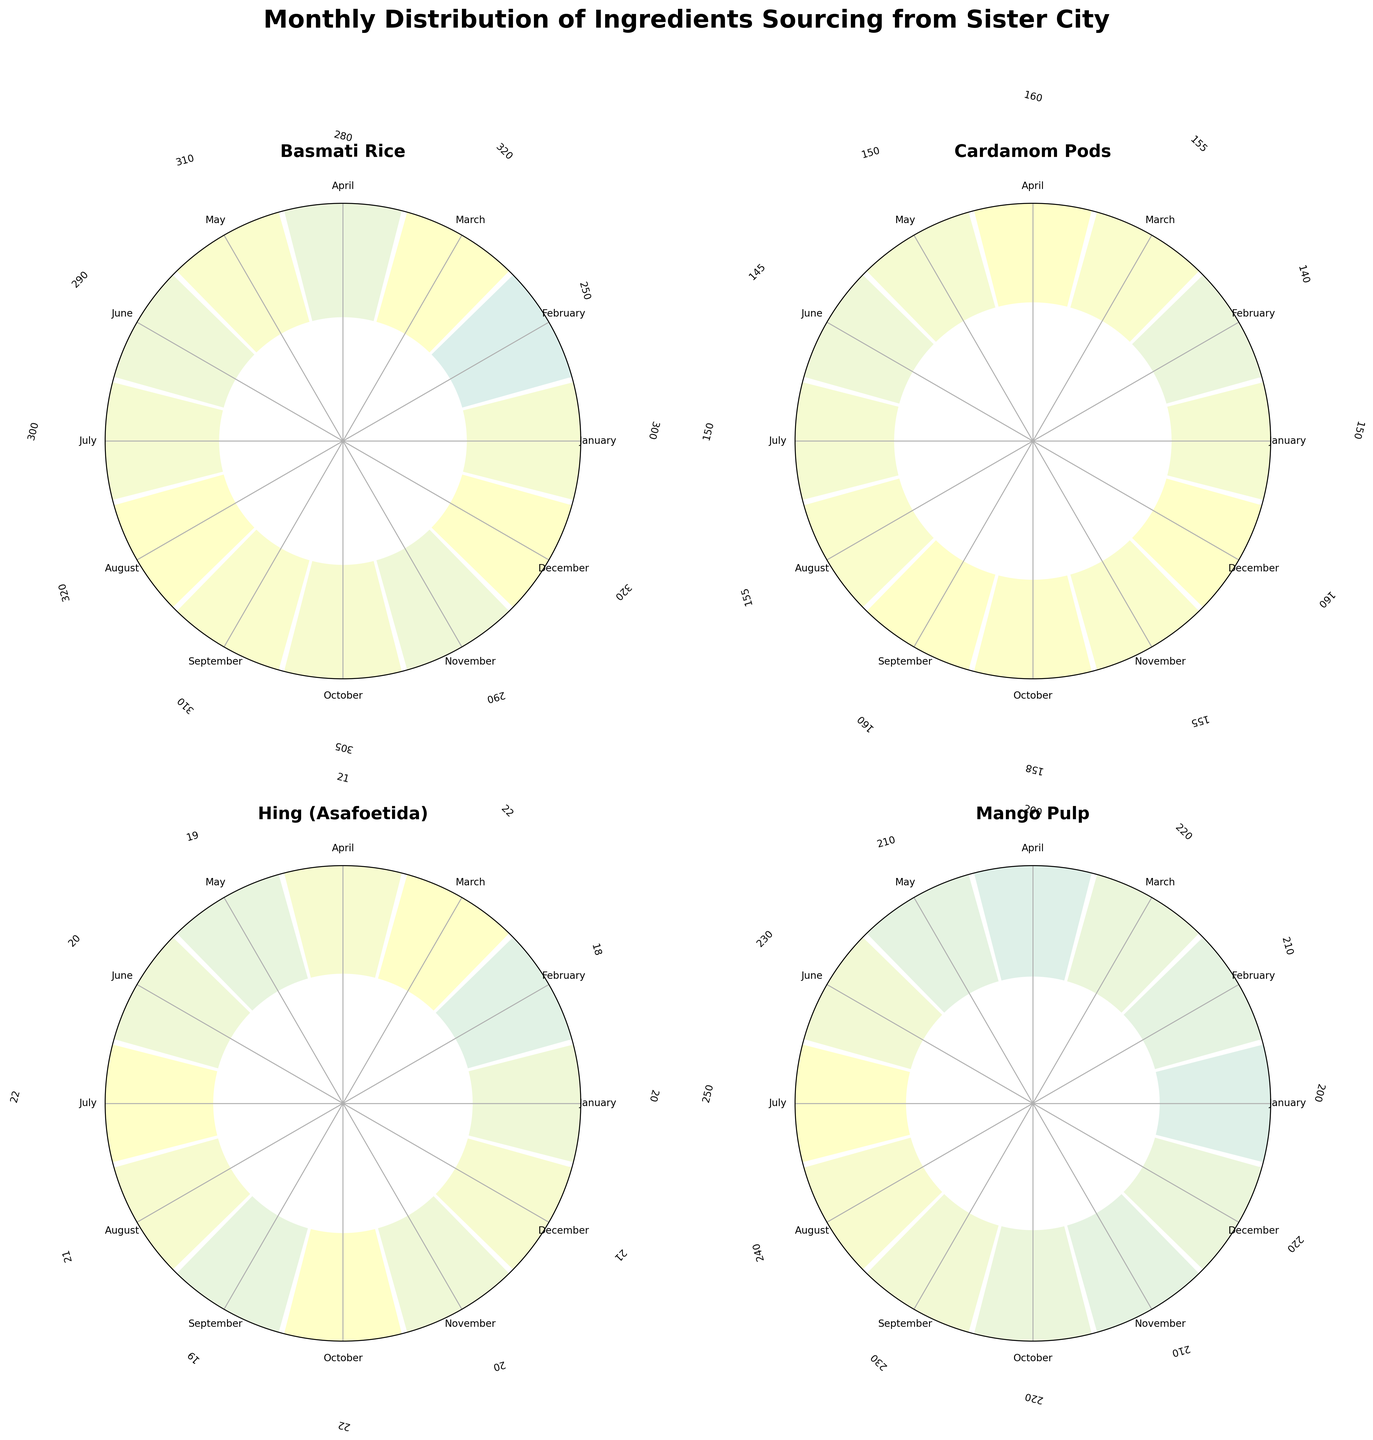What is the title of the chart? The title of the chart is located at the top of the figure in a bold and large font size. It summarizes the overall theme of the visualization.
Answer: "Monthly Distribution of Ingredients Sourcing from Sister City" Which ingredient has the highest value in December? By observing the subplots and focusing on the labels for December, we can compare the values for each ingredient to determine which one has the highest value in that month.
Answer: Basmati Rice How does the sourcing of Mango Pulp in July compare to June? We need to look at the segment for Mango Pulp and compare the heights of the bars for July and June.
Answer: July has a higher value than June What is the average sourcing value for Cardamom Pods across all months? To calculate the average, sum up the values for Cardamom Pods for each month and then divide by the number of months. The values are: 150, 140, 155, 160, 150, 145, 150, 155, 160, 158, 155, 160. This sums up to 1838, and there are 12 months. 1838 / 12 = 153.17
Answer: 153.17 Which month has the lowest sourcing value for Hing (Asafoetida)? By examining the subplot for Hing (Asafoetida), we can identify the month where the bar is the shortest, which corresponds to the lowest value.
Answer: February Is there any ingredient that shows a significant increase in sourcing from November to December? We need to analyze the bars for November and December for each ingredient to see if there is a noticeable jump.
Answer: Basmati Rice What is the median value for Basmati Rice's sourcing across the year? The median is the middle number when the values are sorted in order. The values are: 250, 280, 290, 290, 300, 300, 305, 310, 310, 320, 320, 320. Since there are 12 values, the median is the average of the 6th and 7th values: (300 + 305) / 2 = 302.5
Answer: 302.5 What is the sourcing difference for Mango Pulp between the month with the highest value and the month with the lowest value? First, find the highest and lowest values for Mango Pulp by observing the heights of the bars across all months. The values are: 250 (July, highest) and 200 (January & April, lowest). Difference = 250 - 200 = 50
Answer: 50 In which month does Cardamom Pods have the same sourcing value as Hing (Asafoetida)? We compare the bars for Cardamom Pods and Hing (Asafoetida) to identify a month where the sourcing values are identical.
Answer: March Can you rank the ingredients based on their maximum monthly sourcing value? Identify the highest value for each ingredient from their respective subplots and then rank them. Basmati Rice's highest is 320, Cardamom Pods’ is 160, Hing (Asafoetida)’s is 22, and Mango Pulp's is 250. Order: Basmati Rice, Mango Pulp, Cardamom Pods, Hing (Asafoetida)
Answer: Basmati Rice, Mango Pulp, Cardamom Pods, Hing (Asafoetida) 